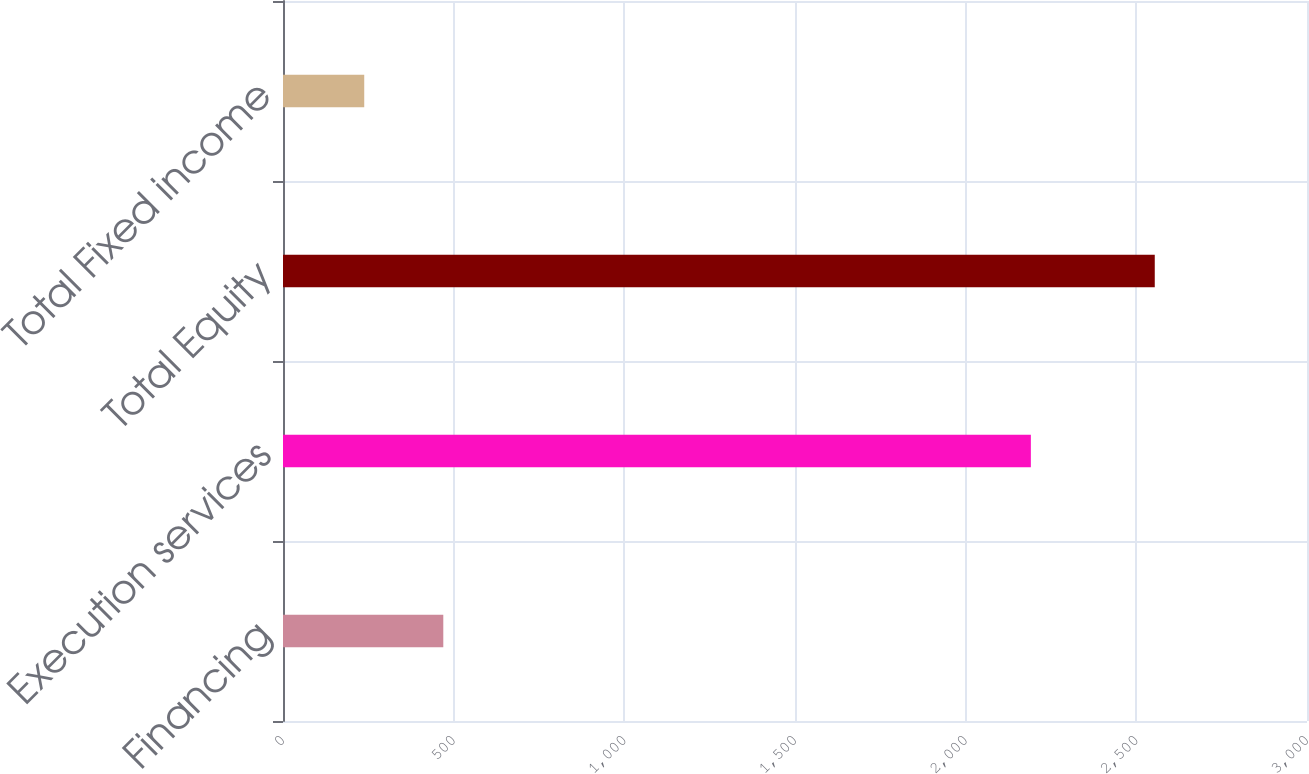Convert chart to OTSL. <chart><loc_0><loc_0><loc_500><loc_500><bar_chart><fcel>Financing<fcel>Execution services<fcel>Total Equity<fcel>Total Fixed income<nl><fcel>469.6<fcel>2191<fcel>2554<fcel>238<nl></chart> 